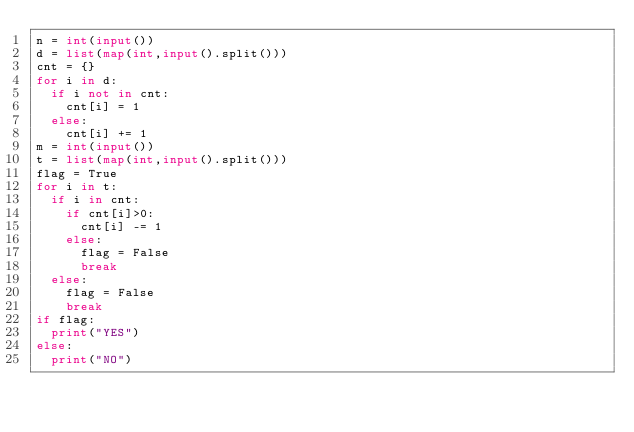Convert code to text. <code><loc_0><loc_0><loc_500><loc_500><_Python_>n = int(input())
d = list(map(int,input().split()))
cnt = {}
for i in d:
  if i not in cnt:
    cnt[i] = 1
  else:
    cnt[i] += 1
m = int(input())
t = list(map(int,input().split()))
flag = True
for i in t:
  if i in cnt:
    if cnt[i]>0:
      cnt[i] -= 1
    else:
      flag = False
      break
  else:
    flag = False
    break
if flag:
  print("YES")
else:
  print("NO")
</code> 